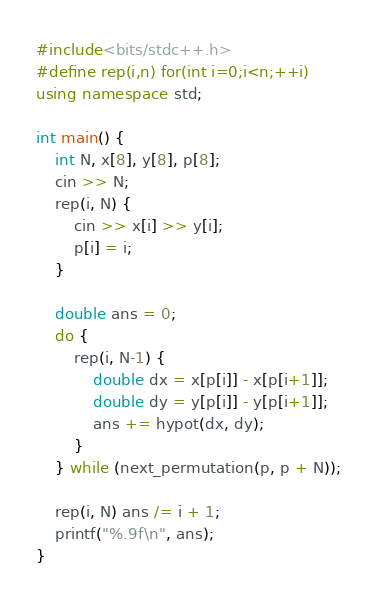Convert code to text. <code><loc_0><loc_0><loc_500><loc_500><_C++_>#include<bits/stdc++.h>
#define rep(i,n) for(int i=0;i<n;++i)
using namespace std;

int main() {
    int N, x[8], y[8], p[8];
    cin >> N;
    rep(i, N) {
        cin >> x[i] >> y[i];
        p[i] = i;
    }

    double ans = 0;
    do {
        rep(i, N-1) {
            double dx = x[p[i]] - x[p[i+1]];
            double dy = y[p[i]] - y[p[i+1]];
            ans += hypot(dx, dy);
        }
    } while (next_permutation(p, p + N));

    rep(i, N) ans /= i + 1;
    printf("%.9f\n", ans);
}</code> 